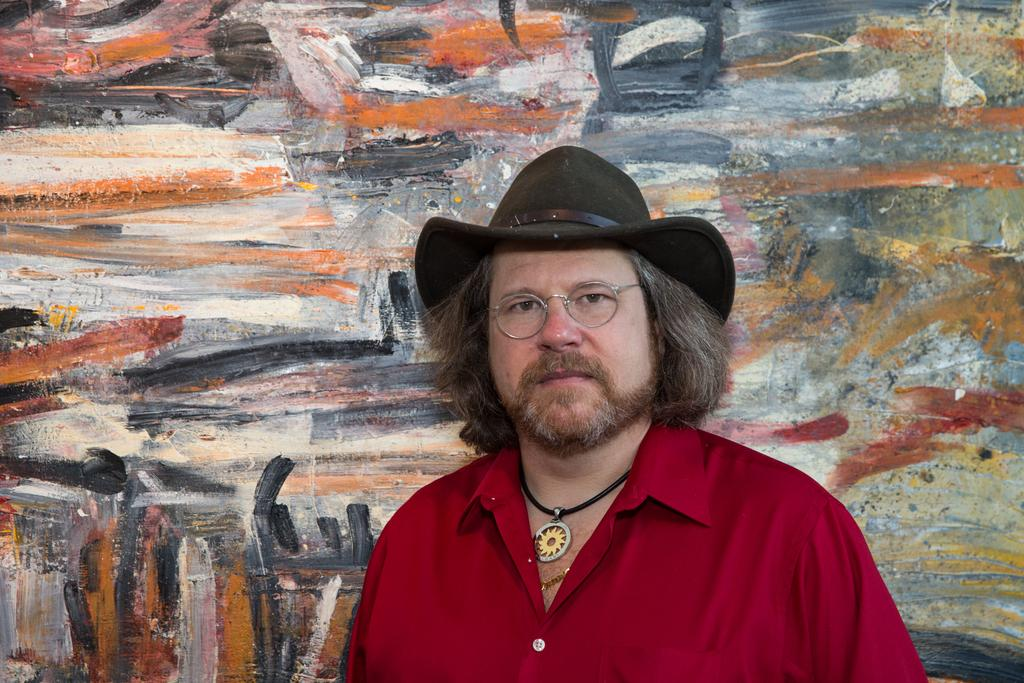Who or what is present in the image? There is a person in the image. What is the person wearing on their upper body? The person is wearing a red shirt. What type of headwear is the person wearing? The person is wearing a black hat. What can be seen in the background of the image? There is a painting on the wall in the background of the image. What type of treatment is the person receiving in the image? There is no indication in the image that the person is receiving any treatment. 